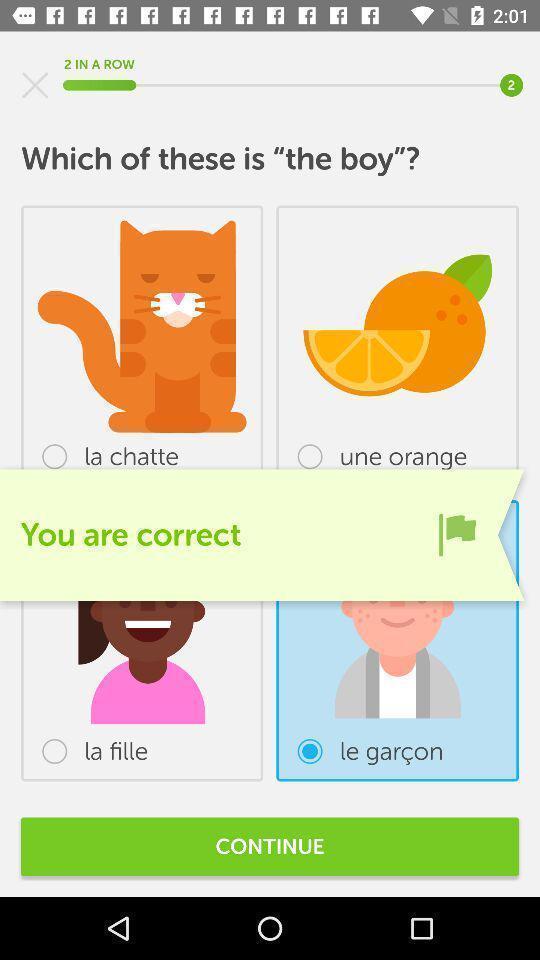Provide a textual representation of this image. Page shows you are correct an language learning application. 